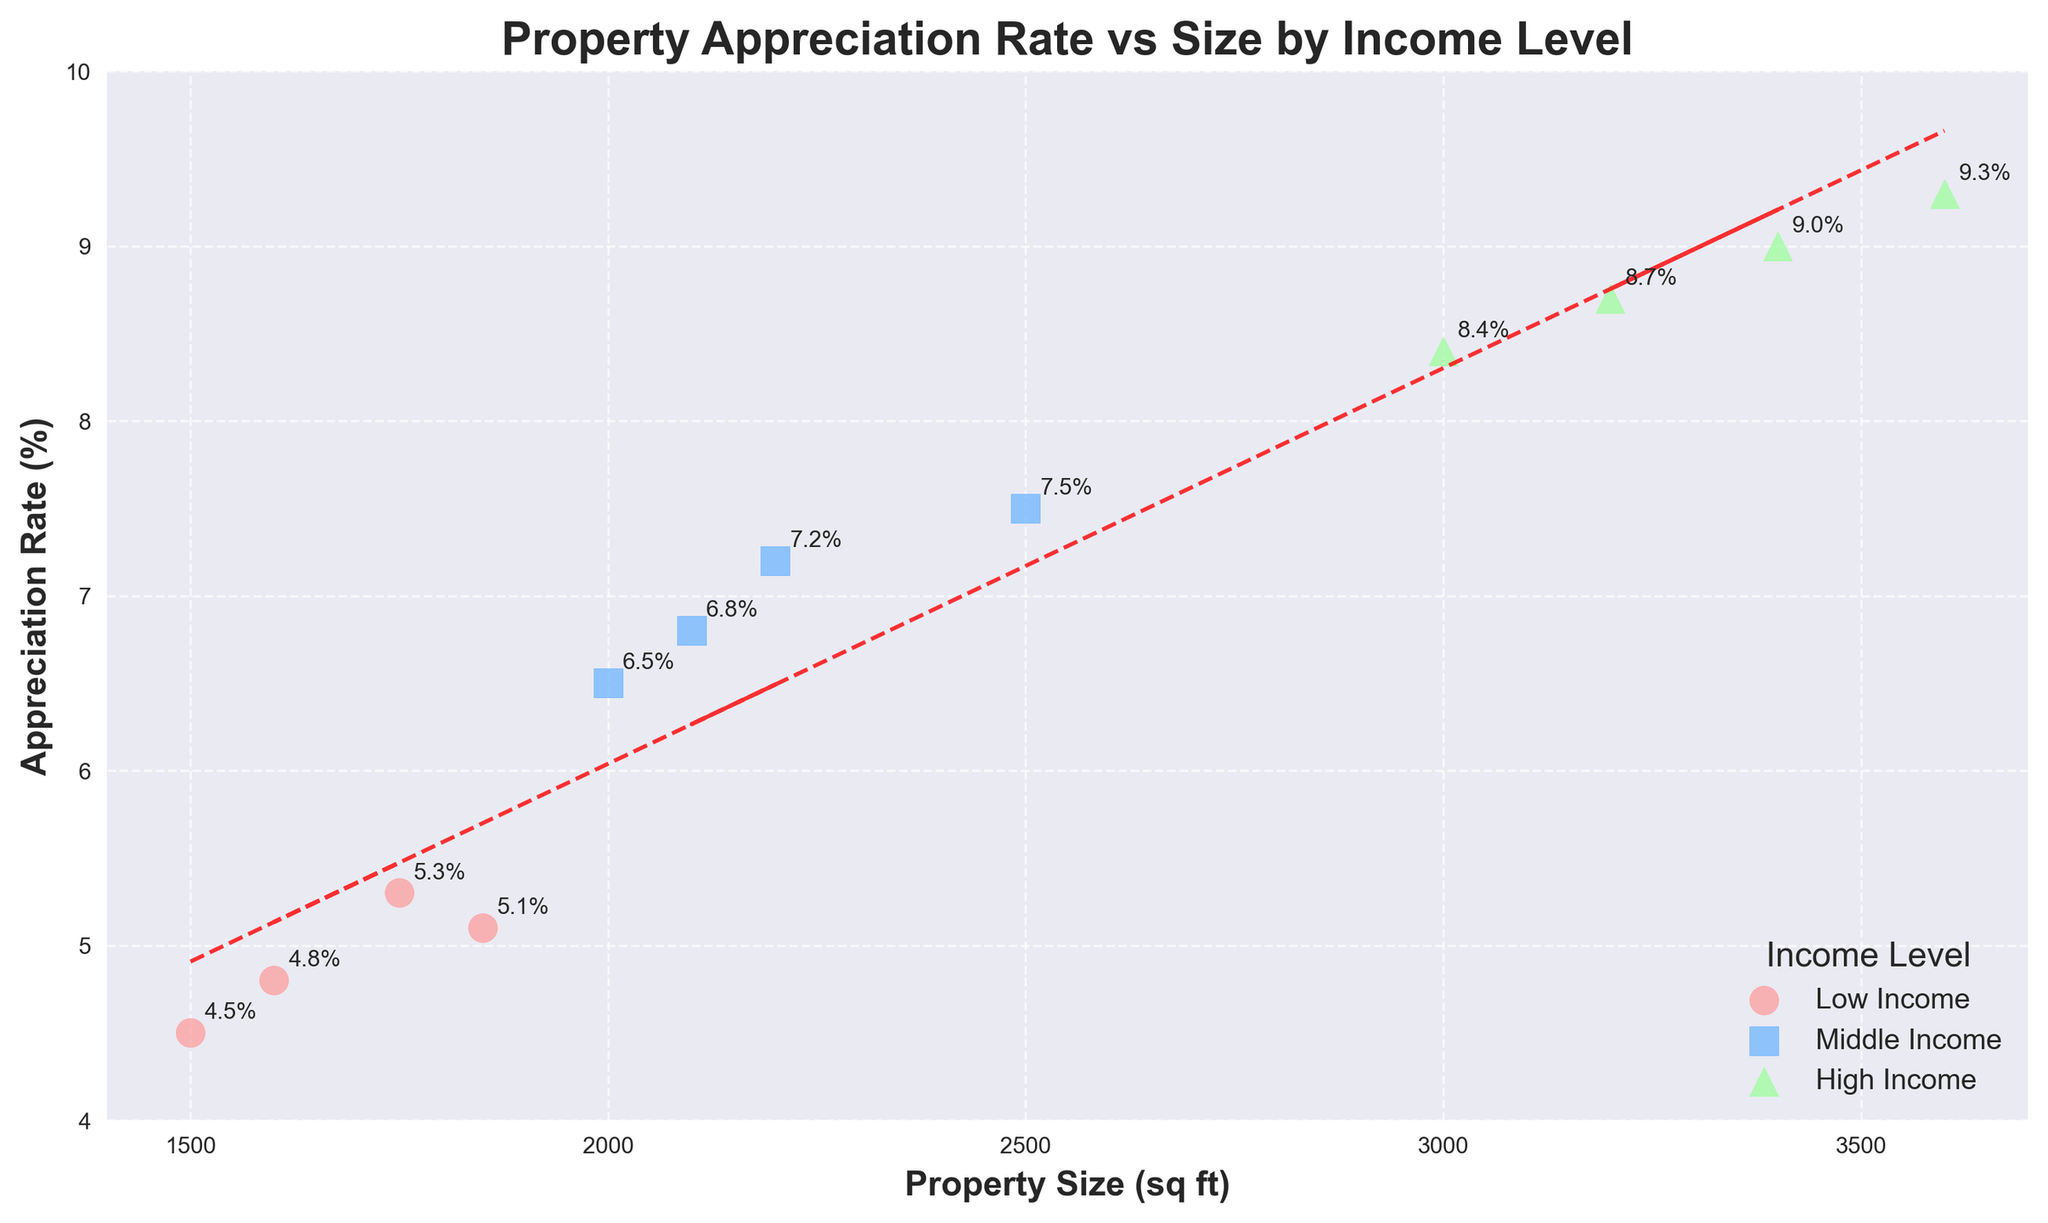What is the title of the plot? The title of the plot is usually displayed at the top, and in this case, it is "Property Appreciation Rate vs Size by Income Level" as specified in the code.
Answer: Property Appreciation Rate vs Size by Income Level What does the x-axis represent? The x-axis represents 'Property Size (sq ft)', which is indicated both by the axis label and the range of values typically associated with property sizes.
Answer: Property Size (sq ft) How many data points represent the 'High' income level? By checking the legend and identifying the markers and colors associated with 'High' income, and then counting these markers on the plot, there are four such points.
Answer: 4 Which income level has the highest appreciation rate? By examining the plot, the 'High' income level shows the highest appreciation rate with the value of 9.3% annotated near a data point.
Answer: High Is there a trend between property size and appreciation rate? Assessing the trend line added to the plot, it appears to show a positive slope, indicating that larger property sizes tend to have higher appreciation rates.
Answer: Yes What's the range of property sizes for the 'Middle' income level? By checking the x-coordinates associated with the 'Middle' income level markers, the smallest size is 2000 sq ft and the largest is 2500 sq ft.
Answer: 2000-2500 sq ft Which income level shows the smallest property size and what is its appreciation rate? The 'Low' income level has the smallest property size of 1500 sq ft, and the appreciation rate of this property is 4.5%, as annotated near the data point.
Answer: Low, 4.5% How do the average appreciation rates compare across income levels? Calculate the average for each level and compare: Low (4.925%), Middle (6.75%), High (8.85%). Comparing these averages, 'High' income level has the highest appreciation rate, followed by 'Middle', and then 'Low'.
Answer: High > Middle > Low What's the appreciation rate range across the entire dataset? Checking all the data points, the lowest appreciation rate is 4.5% and the highest is 9.3%, so the range is 4.5% to 9.3%.
Answer: 4.5%-9.3% Which property size has the highest appreciation rate in the 'Middle' income level? By looking at the 'Middle' income level data points, the highest appreciation rate is 7.5% for the property size of 2500 sq ft.
Answer: 2500 sq ft, 7.5% 